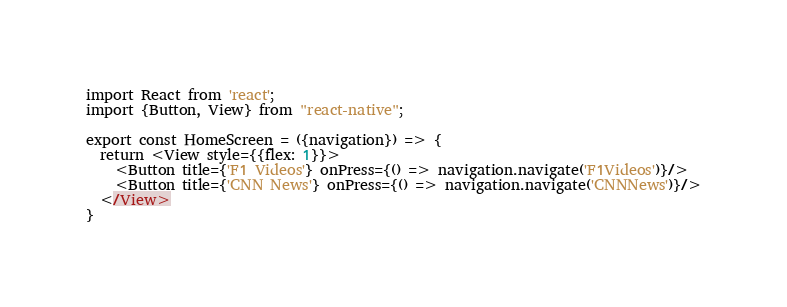<code> <loc_0><loc_0><loc_500><loc_500><_JavaScript_>import React from 'react';
import {Button, View} from "react-native";

export const HomeScreen = ({navigation}) => {
  return <View style={{flex: 1}}>
    <Button title={'F1 Videos'} onPress={() => navigation.navigate('F1Videos')}/>
    <Button title={'CNN News'} onPress={() => navigation.navigate('CNNNews')}/>
  </View>
}
</code> 